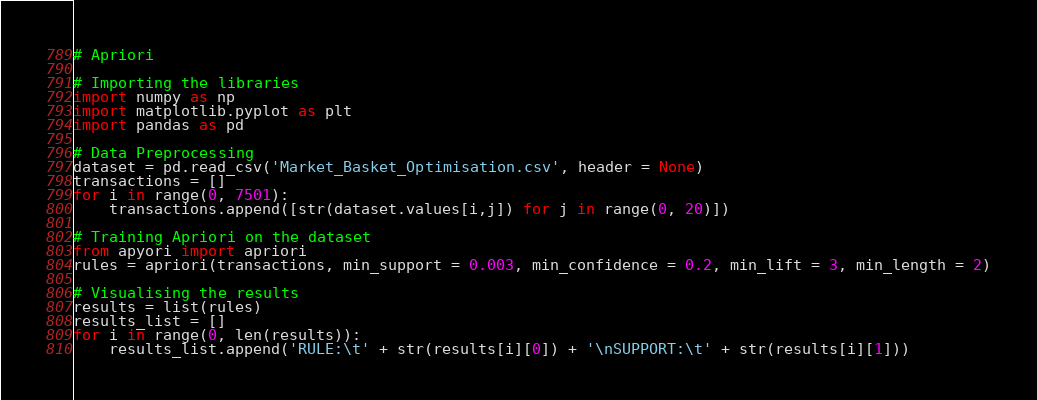Convert code to text. <code><loc_0><loc_0><loc_500><loc_500><_Python_># Apriori

# Importing the libraries
import numpy as np
import matplotlib.pyplot as plt
import pandas as pd

# Data Preprocessing
dataset = pd.read_csv('Market_Basket_Optimisation.csv', header = None)
transactions = []
for i in range(0, 7501):
    transactions.append([str(dataset.values[i,j]) for j in range(0, 20)])

# Training Apriori on the dataset
from apyori import apriori
rules = apriori(transactions, min_support = 0.003, min_confidence = 0.2, min_lift = 3, min_length = 2)

# Visualising the results
results = list(rules)
results_list = []
for i in range(0, len(results)):
    results_list.append('RULE:\t' + str(results[i][0]) + '\nSUPPORT:\t' + str(results[i][1]))</code> 